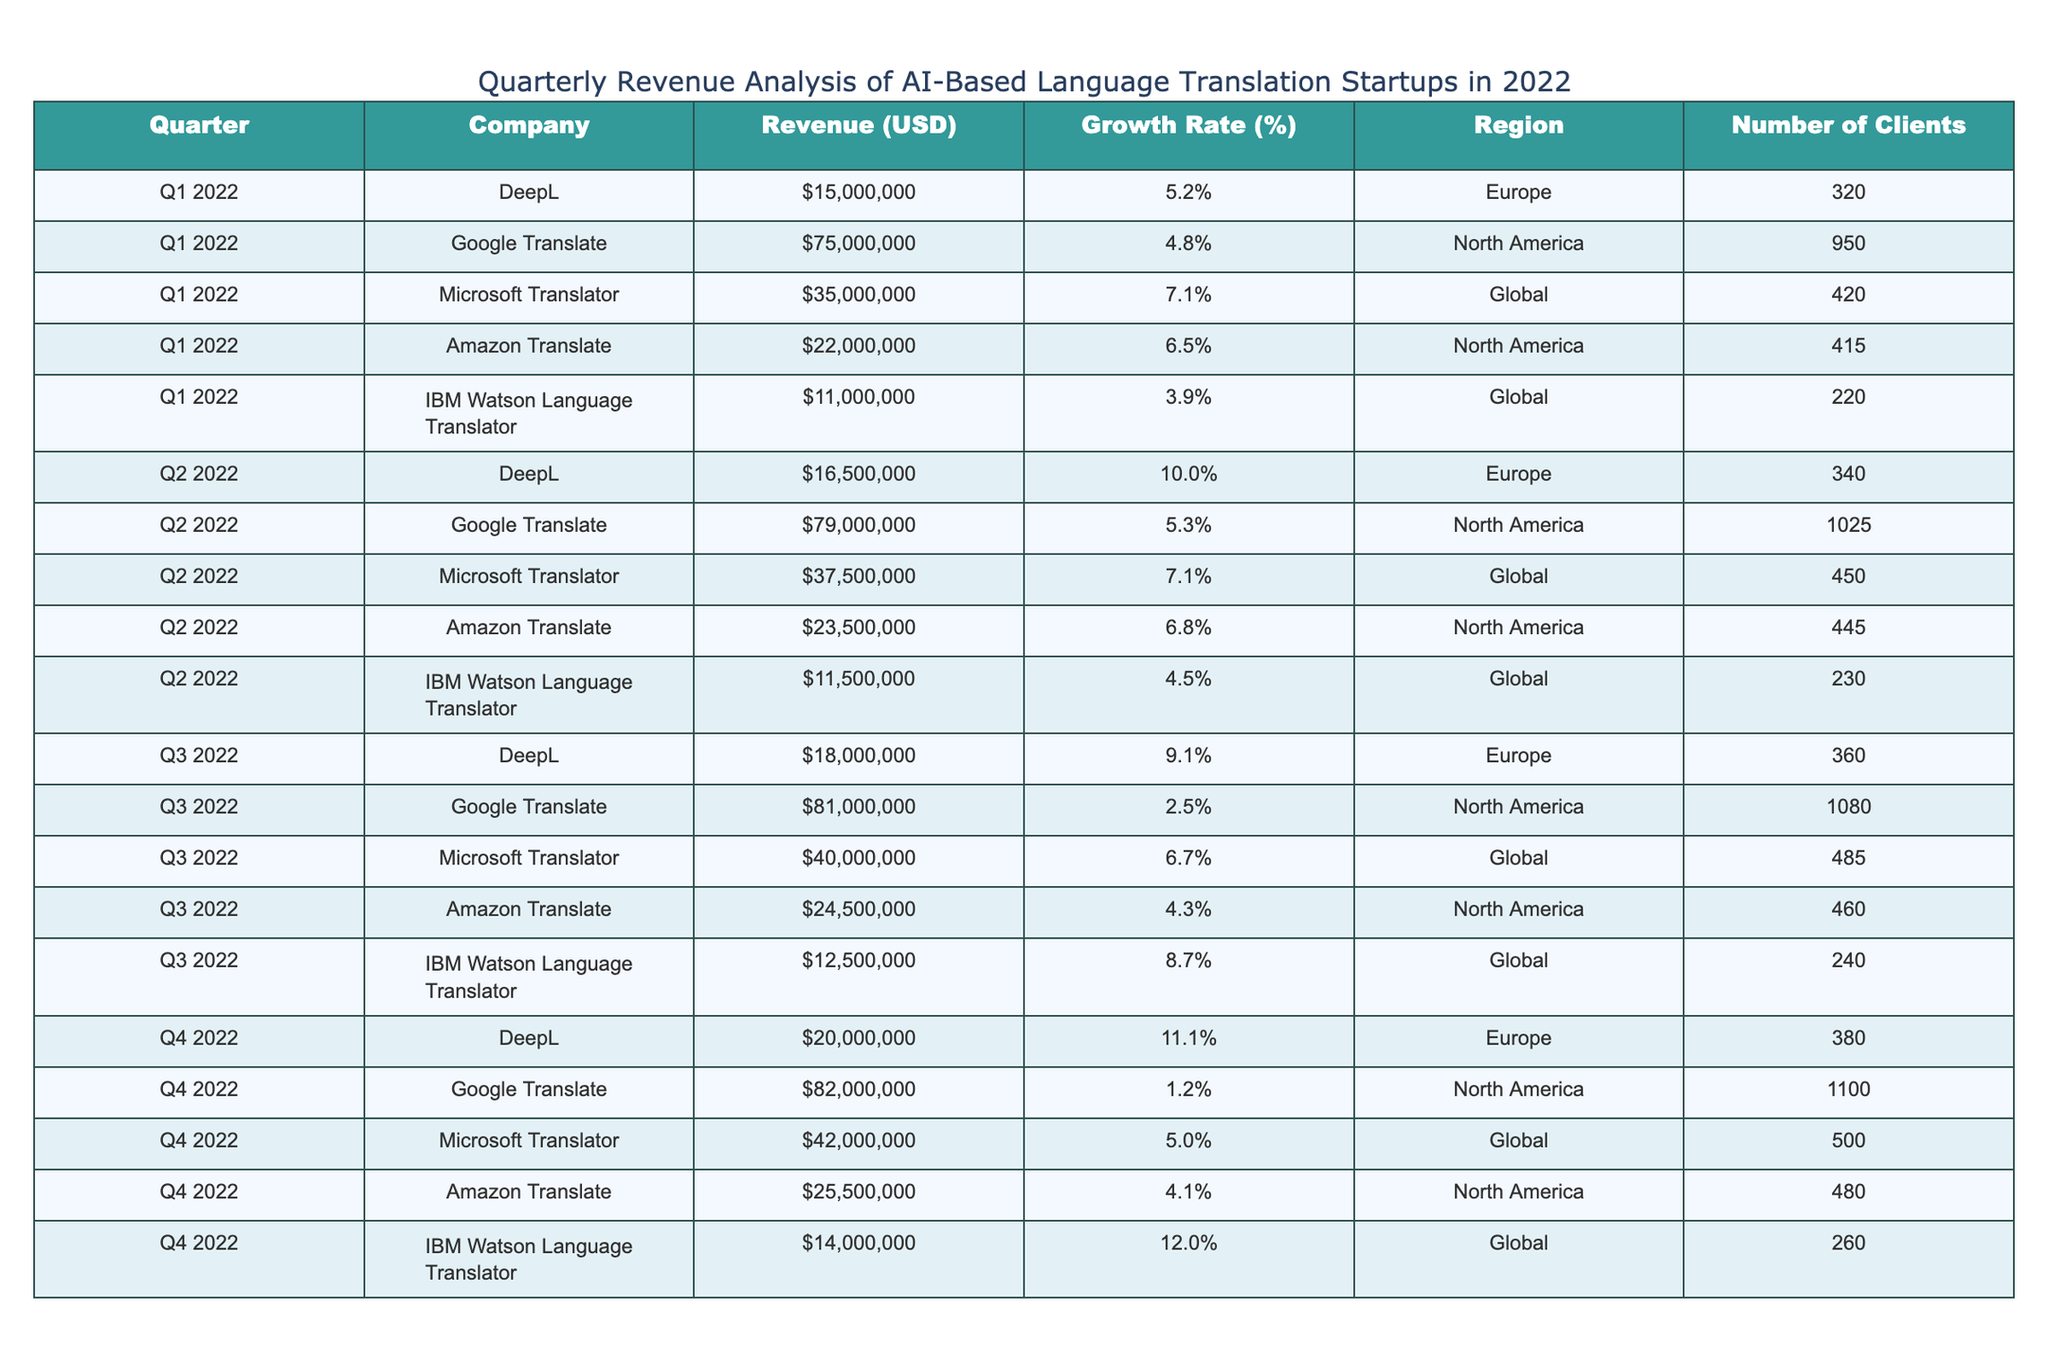What is the revenue of Google Translate in Q4 2022? According to the table, the revenue of Google Translate for Q4 2022 is indicated as $82,000,000.
Answer: $82,000,000 Which company had the highest revenue in Q2 2022? By comparing the revenue values in Q2 2022, Google Translate is indicated to have the highest revenue of $79,000,000. Other companies had lower revenues in that quarter.
Answer: Google Translate What is the growth rate of DeepL from Q1 to Q4 2022? The growth rate for DeepL in Q1 2022 is 5.2% and in Q4 2022 it is 11.1%. The growth can be determined by the difference: 11.1% - 5.2% = 5.9%.
Answer: 5.9% How many clients does Microsoft Translator have in Q3 2022? The table specifies that Microsoft Translator had 485 clients in Q3 2022.
Answer: 485 Did Amazon Translate's revenue increase in Q3 2022 compared to Q2 2022? In Q2 2022, Amazon Translate's revenue was $23,500,000 and in Q3 2022 it was $24,500,000. Since $24,500,000 is greater than $23,500,000, it confirms that there was an increase in revenue.
Answer: Yes What is the average revenue for IBM Watson Language Translator across all quarters in 2022? The revenues for IBM Watson Language Translator are as follows: $11,000,000 (Q1), $11,500,000 (Q2), $12,500,000 (Q3), and $14,000,000 (Q4). Summing those gives $49,000,000, and averaging them by dividing by 4 results in $12,250,000.
Answer: $12,250,000 Which region had the lowest revenue reported for Q2 2022? In Q2 2022, the revenues were $16,500,000 (DeepL), $79,000,000 (Google Translate), $37,500,000 (Microsoft Translator), $23,500,000 (Amazon Translate), and $11,500,000 (IBM Watson). The lowest is from IBM Watson at $11,500,000.
Answer: Global Was there any quarter where the growth rate of DeepL exceeded 10%? Checking the growth rates of DeepL across quarters, Q2 2022 has a growth rate of 10.0% and Q4 2022 has a growth rate of 11.1%, meaning there were two quarters with a growth rate that exceeded 10%.
Answer: Yes What is the total revenue generated by Amazon Translate in 2022? The revenues for Amazon Translate are $22,000,000 (Q1), $23,500,000 (Q2), $24,500,000 (Q3), and $25,500,000 (Q4). Adding these gives $95,500,000.
Answer: $95,500,000 